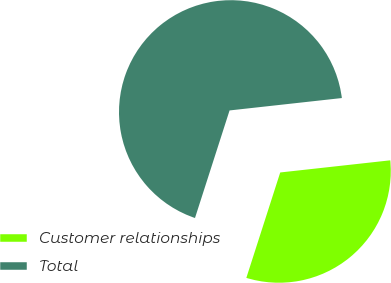<chart> <loc_0><loc_0><loc_500><loc_500><pie_chart><fcel>Customer relationships<fcel>Total<nl><fcel>31.7%<fcel>68.3%<nl></chart> 